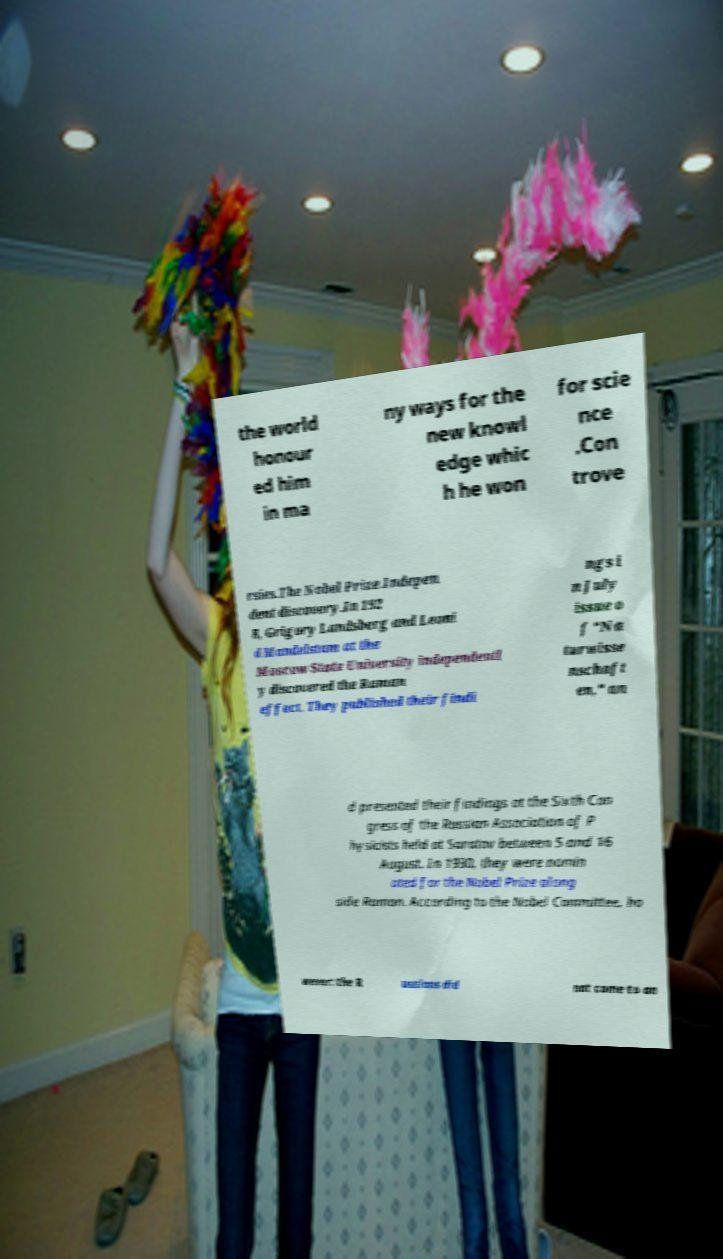Please read and relay the text visible in this image. What does it say? the world honour ed him in ma ny ways for the new knowl edge whic h he won for scie nce .Con trove rsies.The Nobel Prize.Indepen dent discovery.In 192 8, Grigory Landsberg and Leoni d Mandelstam at the Moscow State University independentl y discovered the Raman effect. They published their findi ngs i n July issue o f "Na turwisse nschaft en," an d presented their findings at the Sixth Con gress of the Russian Association of P hysicists held at Saratov between 5 and 16 August. In 1930, they were nomin ated for the Nobel Prize along side Raman. According to the Nobel Committee, ho wever: the R ussians did not come to an 